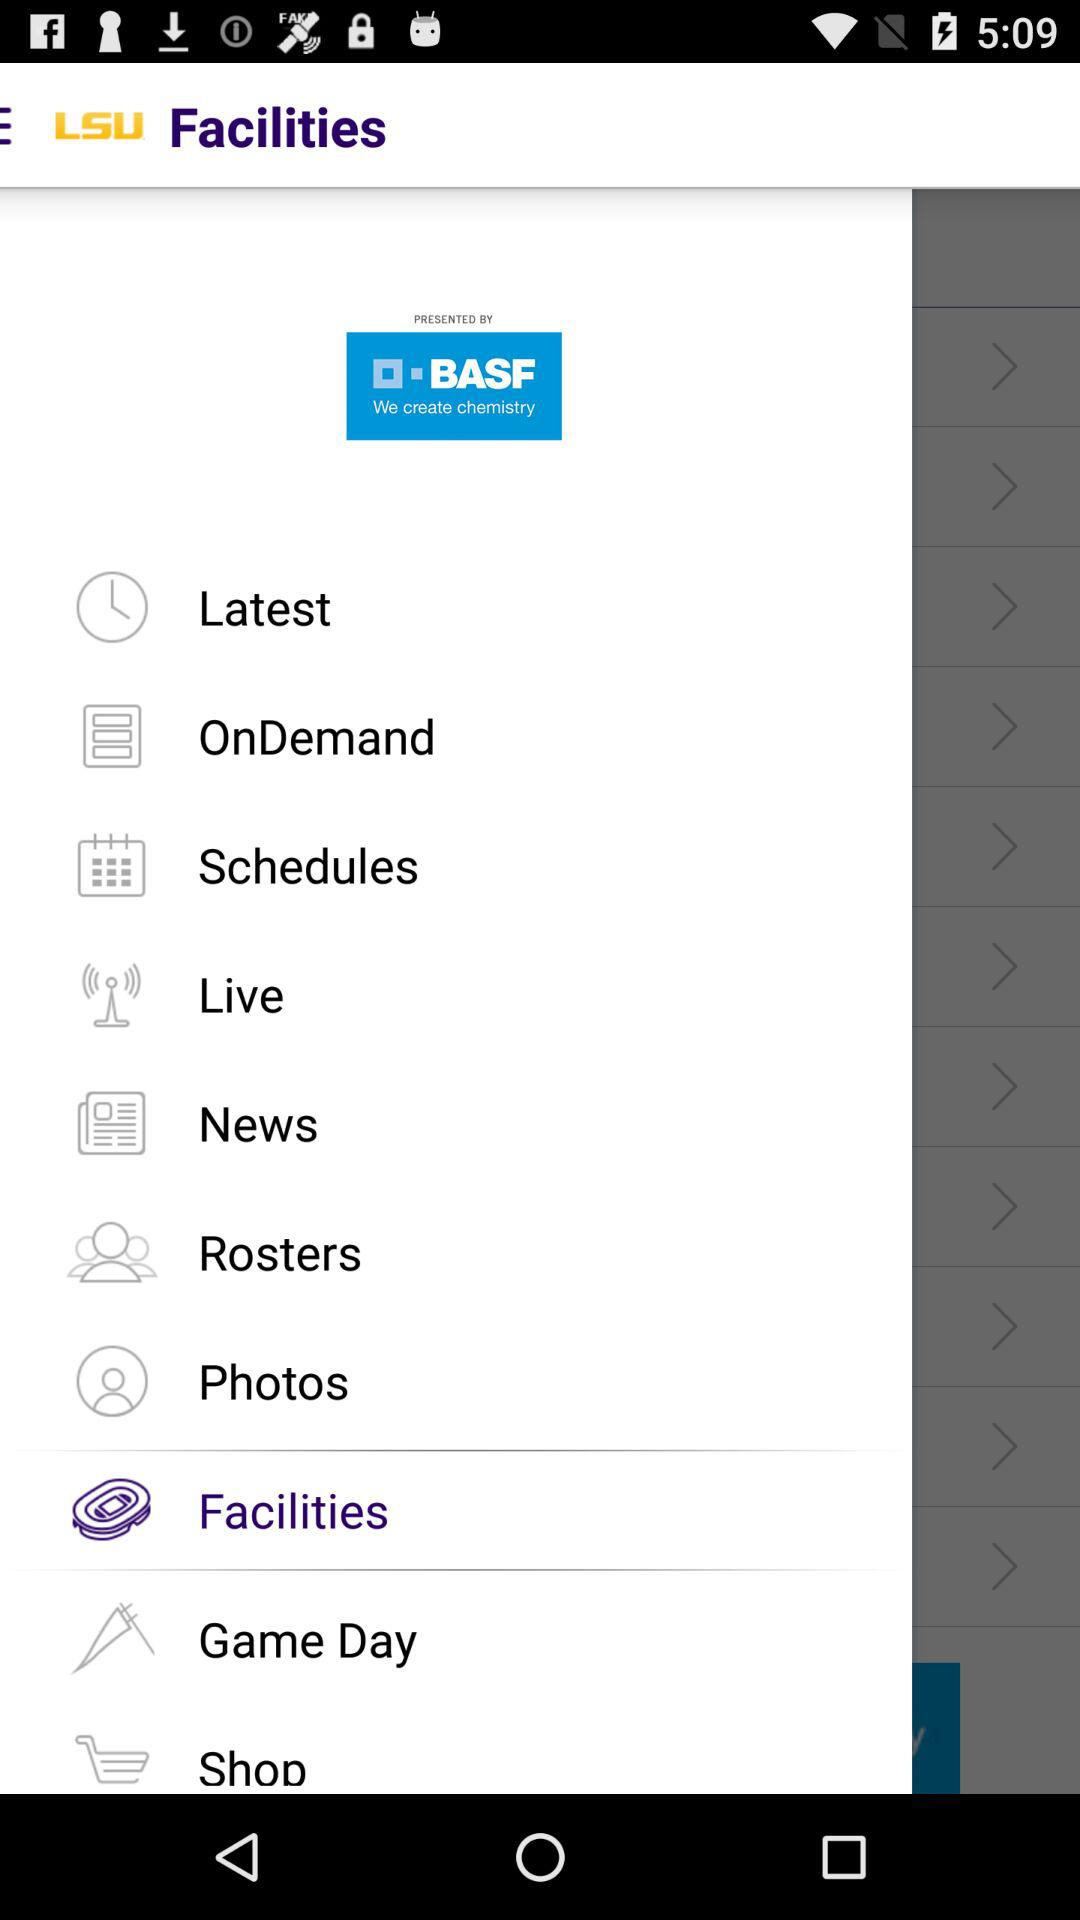What is the application name? The application name is "LSU". 